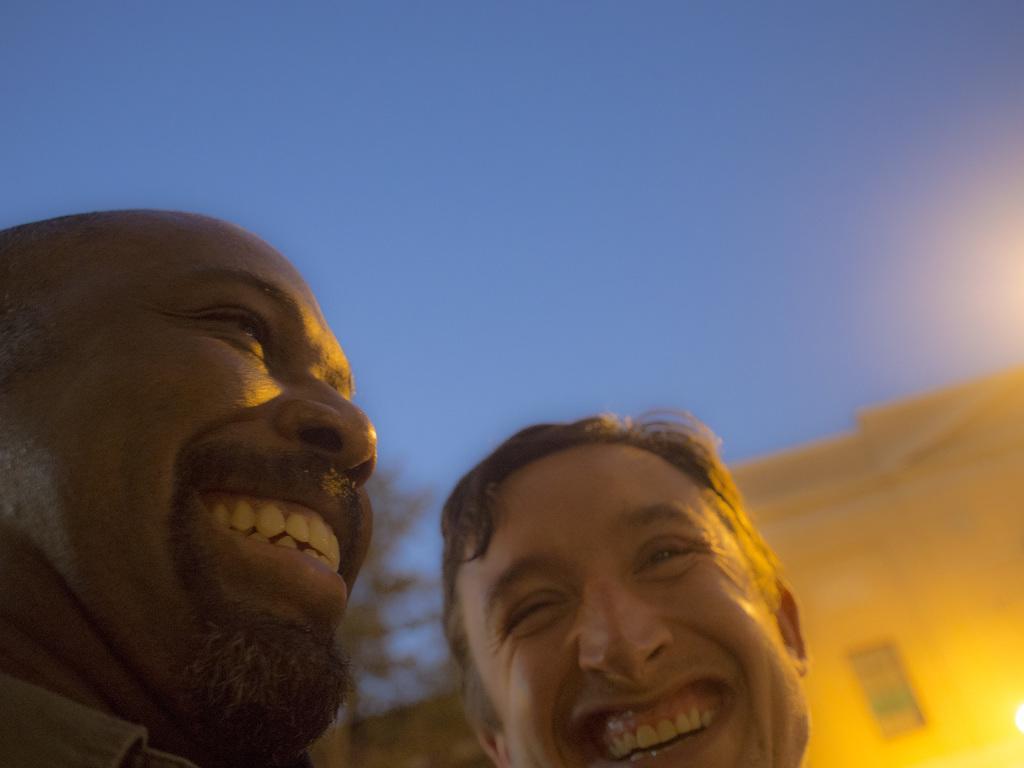Could you give a brief overview of what you see in this image? In this image we can see two persons. Behind the persons we can see a building and a tree. At the top we can see the sky. 